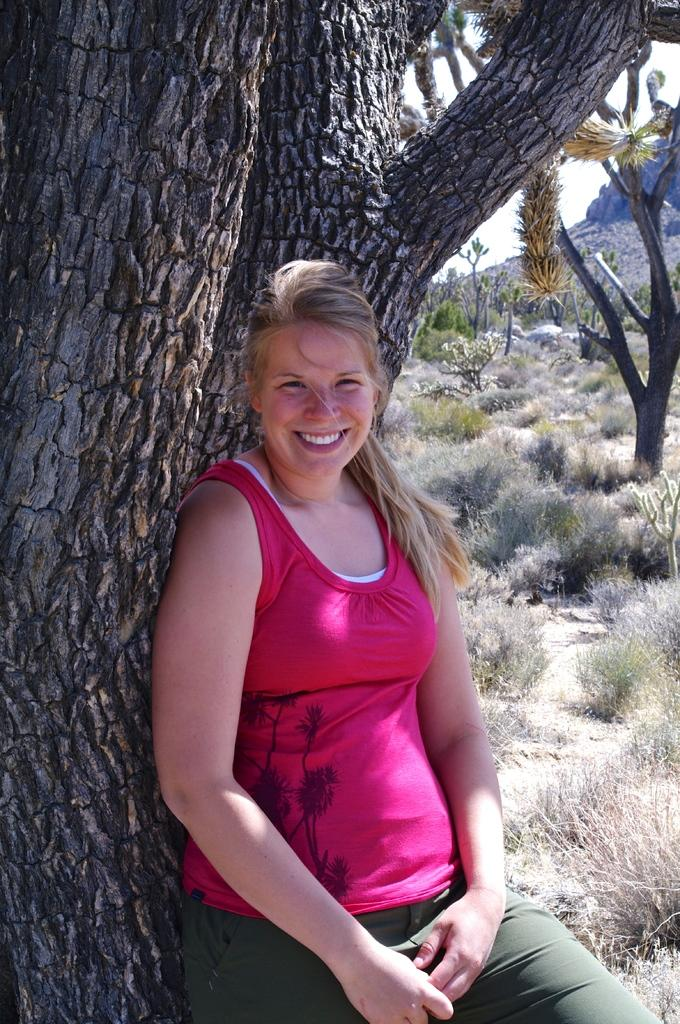Who is the main subject in the image? There is a lady in the image. What is the lady doing in the image? The lady is posing for a picture. What can be seen behind the lady? There are trees behind the lady. What type of natural features are visible in the background of the image? There are mountains, trees, plants, and bushes present in the background of the image. What type of vegetable is being raked in the image? There is no vegetable or rake present in the image. What type of trouble is the lady experiencing in the image? There is no indication of trouble or any negative situation in the image; the lady is posing for a picture. 